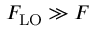Convert formula to latex. <formula><loc_0><loc_0><loc_500><loc_500>F _ { L O } \gg F</formula> 